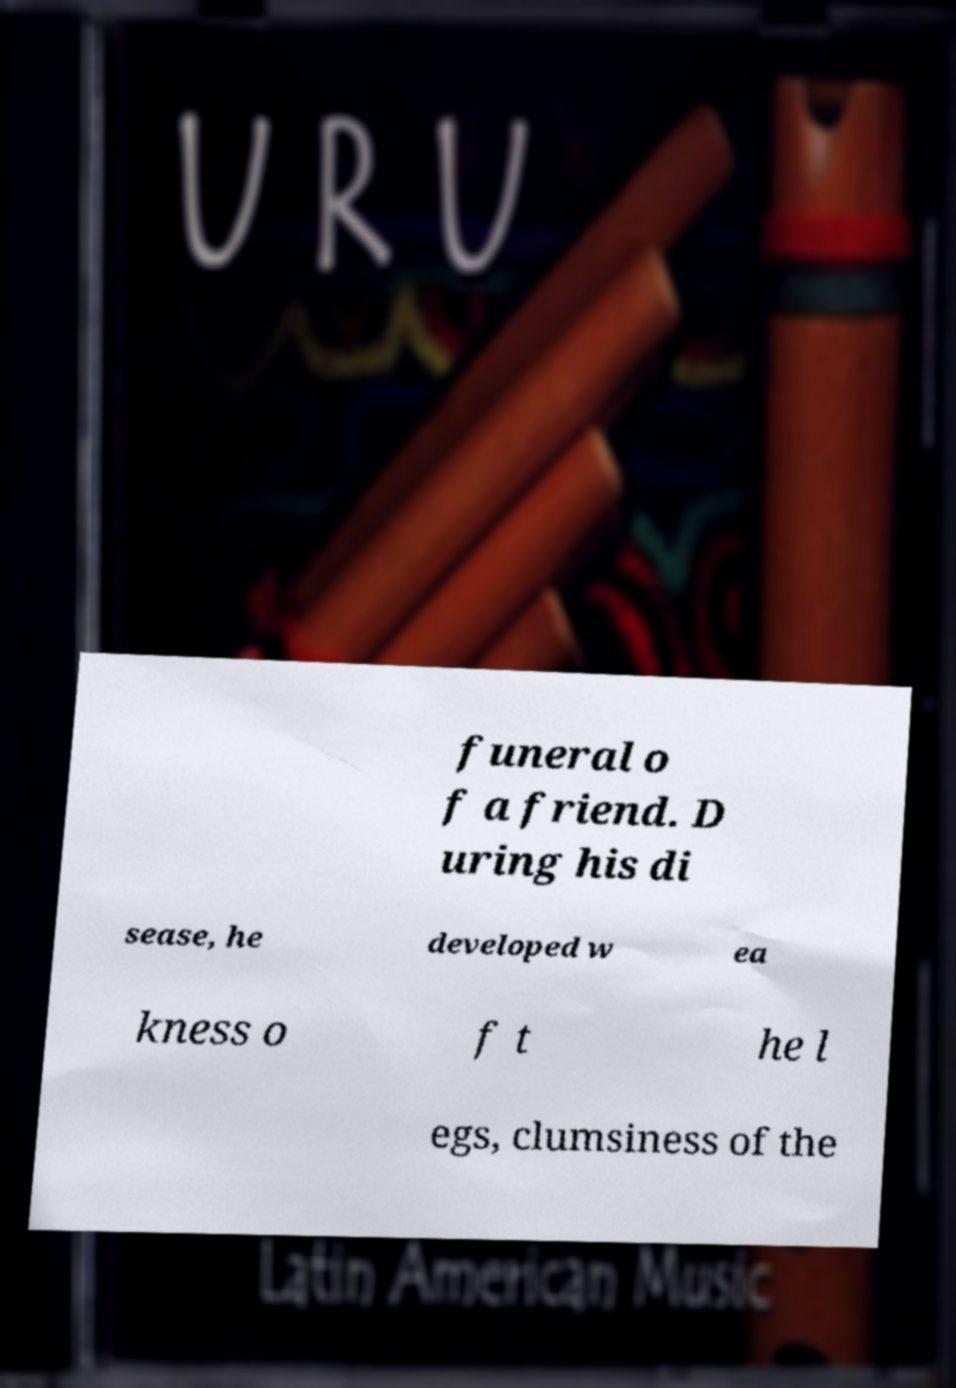Can you accurately transcribe the text from the provided image for me? funeral o f a friend. D uring his di sease, he developed w ea kness o f t he l egs, clumsiness of the 